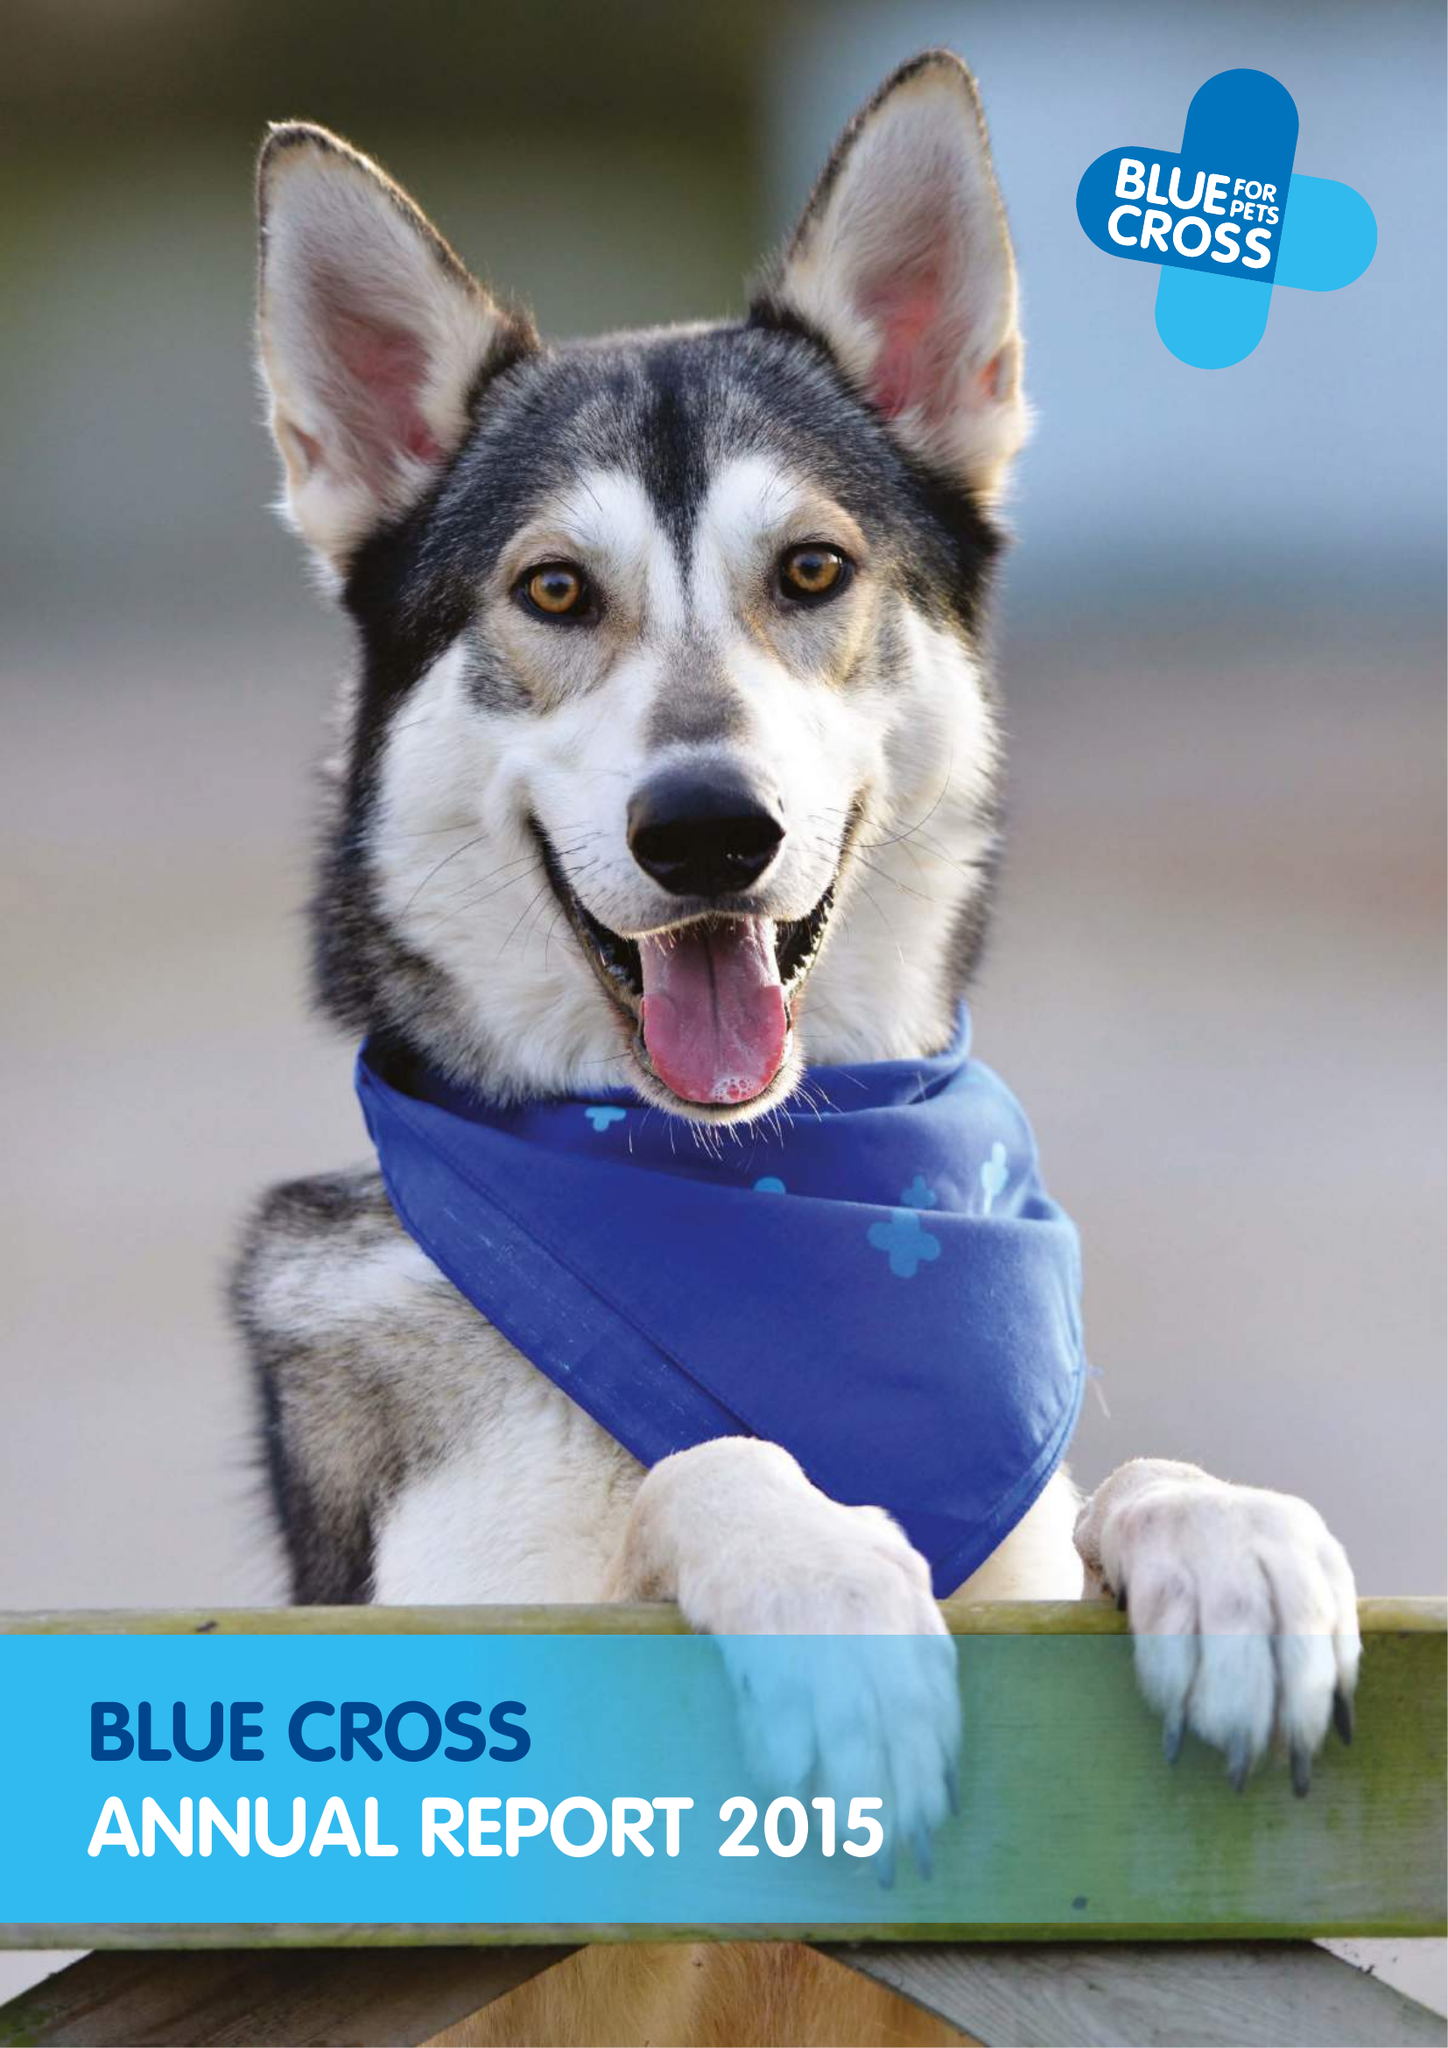What is the value for the charity_number?
Answer the question using a single word or phrase. 224392 